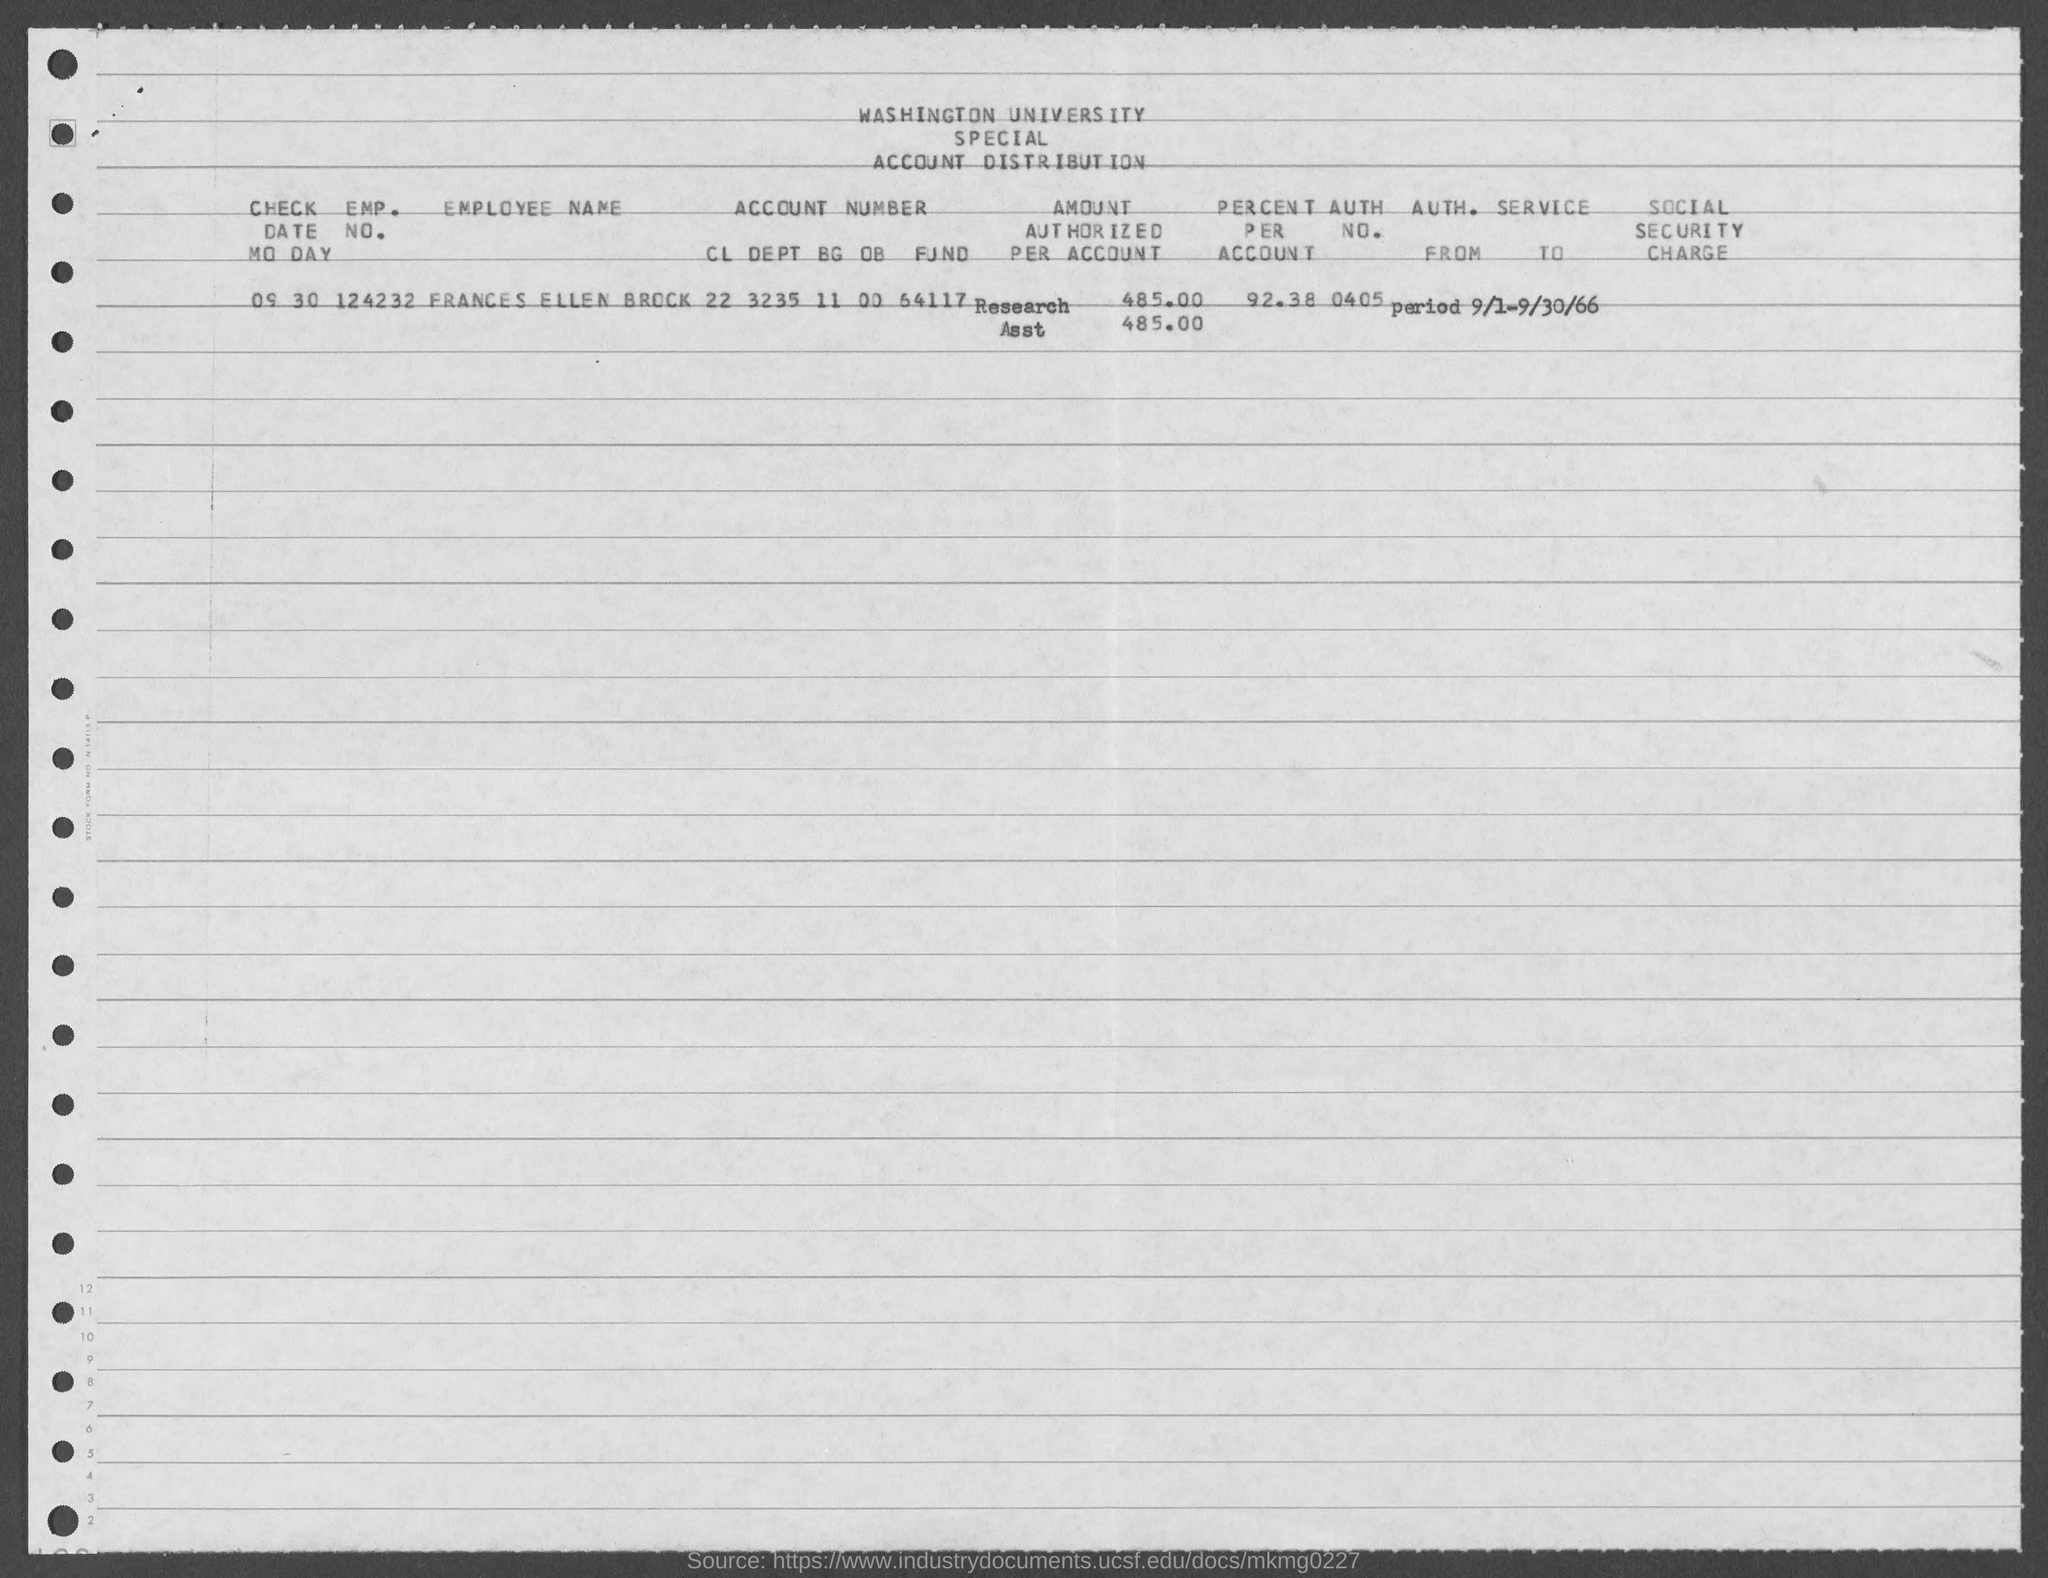What is the employee name ?
Your answer should be compact. Frances Ellen Brock. What is the emp. no. of frances ellen brock ?
Your answer should be very brief. 124232. What is the auth no. of frances ellen brock ?
Your response must be concise. 0405. What is the percent per account of frances ellen brock ?
Keep it short and to the point. 92.38%. 